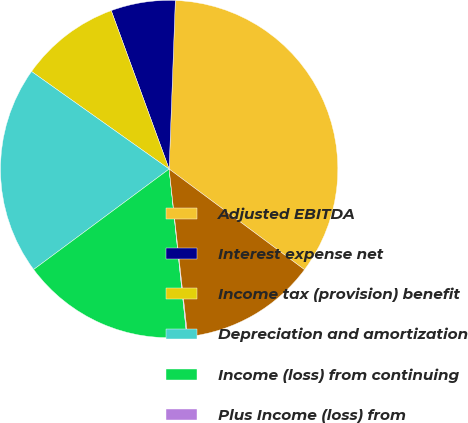<chart> <loc_0><loc_0><loc_500><loc_500><pie_chart><fcel>Adjusted EBITDA<fcel>Interest expense net<fcel>Income tax (provision) benefit<fcel>Depreciation and amortization<fcel>Income (loss) from continuing<fcel>Plus Income (loss) from<fcel>Net income (loss) attributable<nl><fcel>34.59%<fcel>6.16%<fcel>9.61%<fcel>19.97%<fcel>16.52%<fcel>0.08%<fcel>13.07%<nl></chart> 